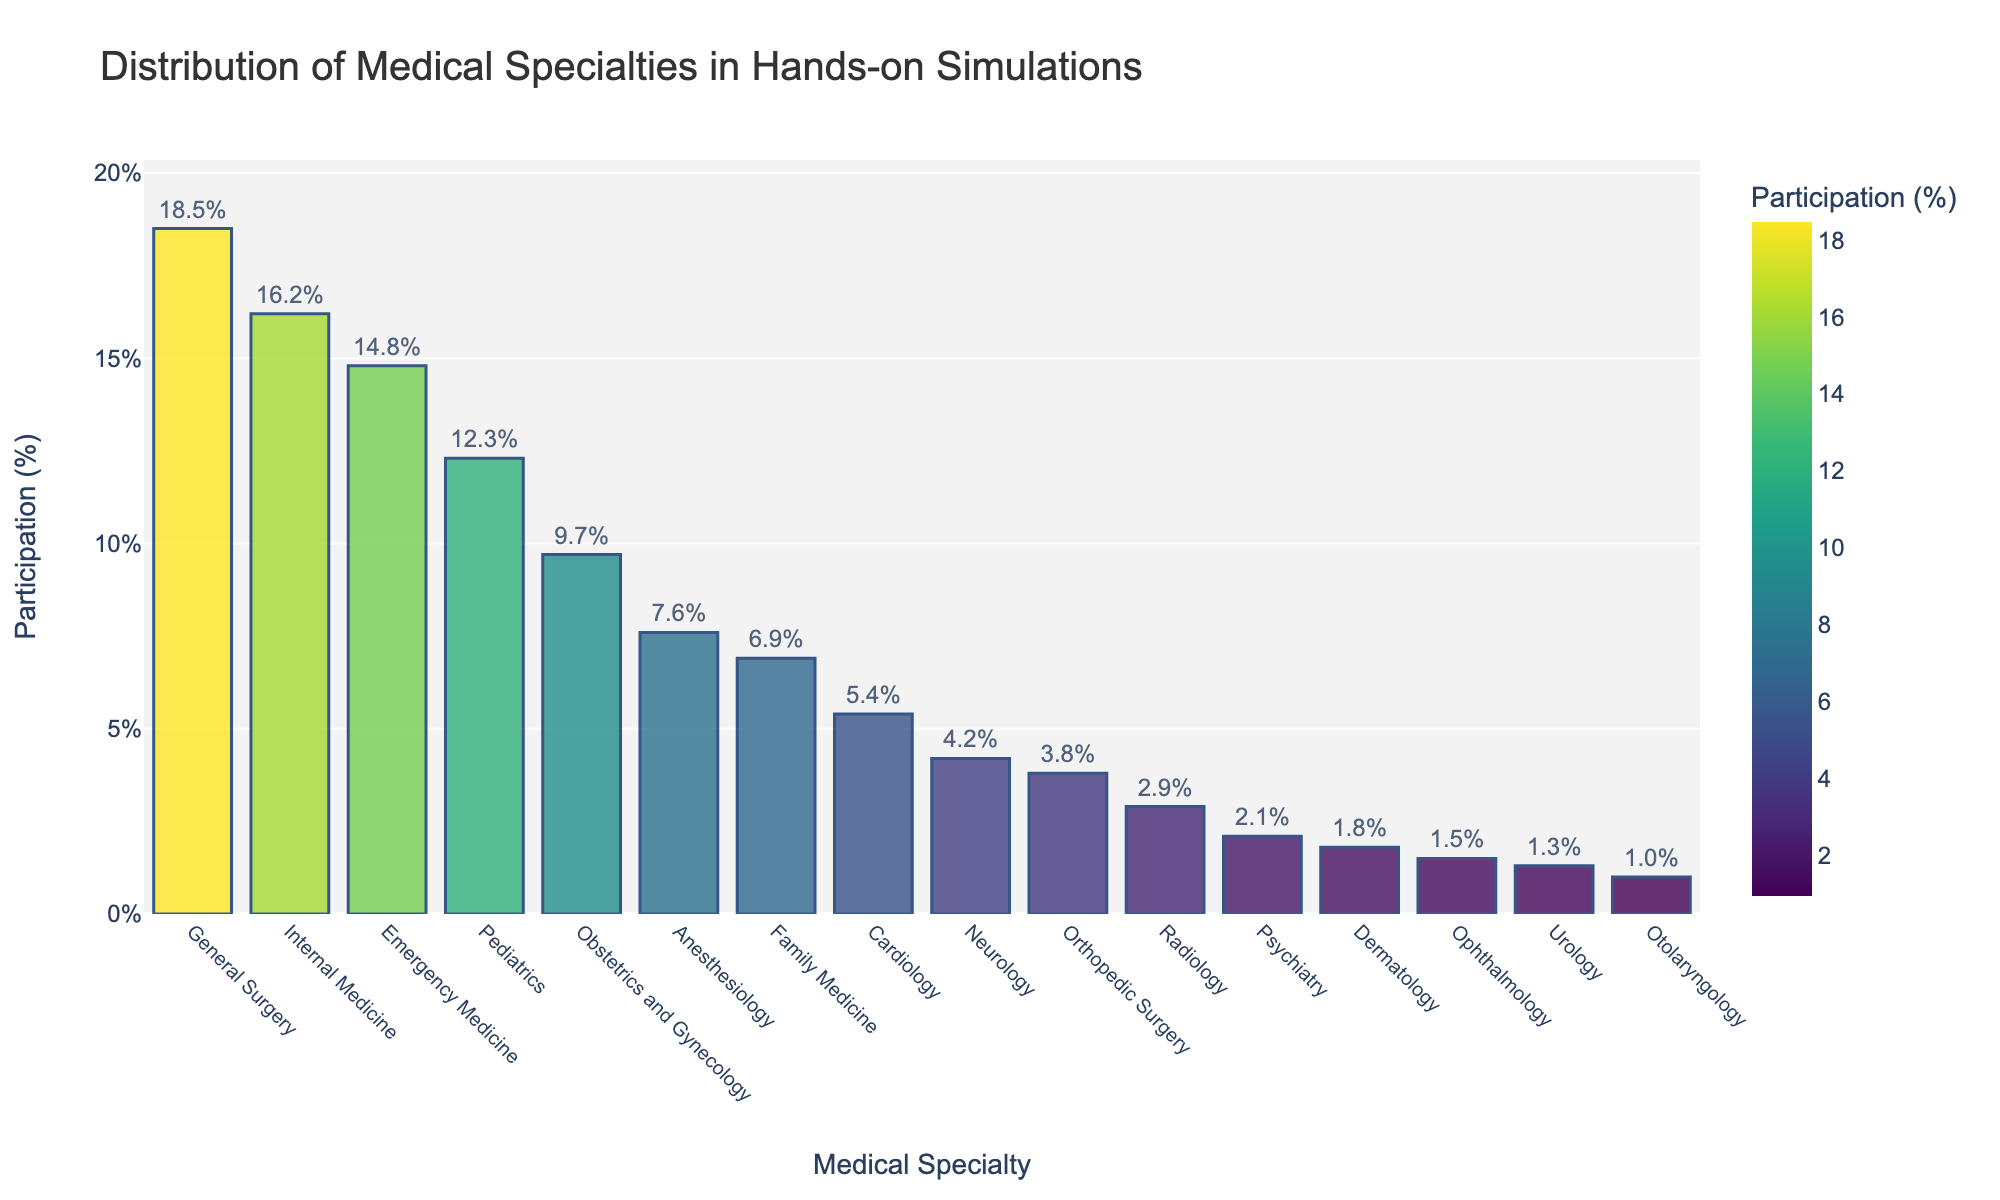Which medical specialty has the highest participation percentage? The figure shows the distribution of medical specialties among participants. The highest bar represents General Surgery at 18.5%.
Answer: General Surgery Which two medical specialties have the closest participation percentages? The figure shows the distribution bars with their respective percentages. Pediatrics and Obstetrics and Gynecology have almost similar heights and percentages, at 12.3% and 9.7%, respectively.
Answer: Pediatrics and Obstetrics and Gynecology What is the combined participation percentage of Family Medicine and Cardiology? Summing the percentages for Family Medicine (6.9%) and Cardiology (5.4%) gives us the combined percentage. 6.9% + 5.4% = 12.3%.
Answer: 12.3% Which specialty has a higher participation percentage, Neurology or Orthopedic Surgery? By comparing the heights of the respective bars, Neurology (4.2%) is higher than Orthopedic Surgery (3.8%).
Answer: Neurology What is the difference in participation percentage between the specialty with the highest value and the specialty with the lowest value? The highest percentage is General Surgery (18.5%) and the lowest is Otolaryngology (1.0%). The difference is 18.5% - 1.0% = 17.5%.
Answer: 17.5% How many specialties have a participation percentage above 10%? The specialties with percentages above 10% are General Surgery (18.5%), Internal Medicine (16.2%), Emergency Medicine (14.8%), and Pediatrics (12.3%). This is 4 specialties in total.
Answer: 4 Which specialty has the lowest participation percentage among those with more than 5%? Specialties with more than 5% are General Surgery, Internal Medicine, Emergency Medicine, Pediatrics, Obstetrics and Gynecology, Anesthesiology, and Family Medicine. Among these, Family Medicine has the lowest percentage at 6.9%.
Answer: Family Medicine Is the participation percentage for Emergency Medicine more than double that of Radiology? Emergency Medicine has 14.8% while Radiology has 2.9%. Checking the calculation, 14.8% > 2 * 2.9% (which is 5.8%), so the participation for Emergency Medicine is indeed more than double.
Answer: Yes What is the total participation percentage for all specialties with less than 2%? Summing the percentages for specialties having less than 2%, we have Dermatology (1.8%), Ophthalmology (1.5%), Urology (1.3%), and Otolaryngology (1.0%). 1.8% + 1.5% + 1.3% + 1.0% = 5.6%.
Answer: 5.6% Which specialty's participation rate is closest to the average participation rate of all specialties? Find the average participation rate for all specialties by summing all percentages and dividing by the number of specialties (16 in total). The sum is 99.4%, thus the average is 99.4% / 16 ≈ 6.2%. Comparing this with individual rates, Family Medicine's rate (6.9%) is the closest.
Answer: Family Medicine 